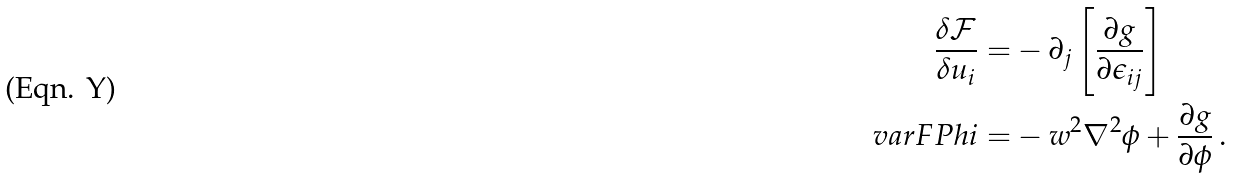Convert formula to latex. <formula><loc_0><loc_0><loc_500><loc_500>\frac { \delta { \mathcal { F } } } { \delta u _ { i } } = & - \partial _ { j } \left [ \frac { \partial g } { \partial \epsilon _ { i j } } \right ] \\ \ v a r F P h i = & - w ^ { 2 } \nabla ^ { 2 } \phi + \frac { \partial g } { \partial \phi } \, .</formula> 